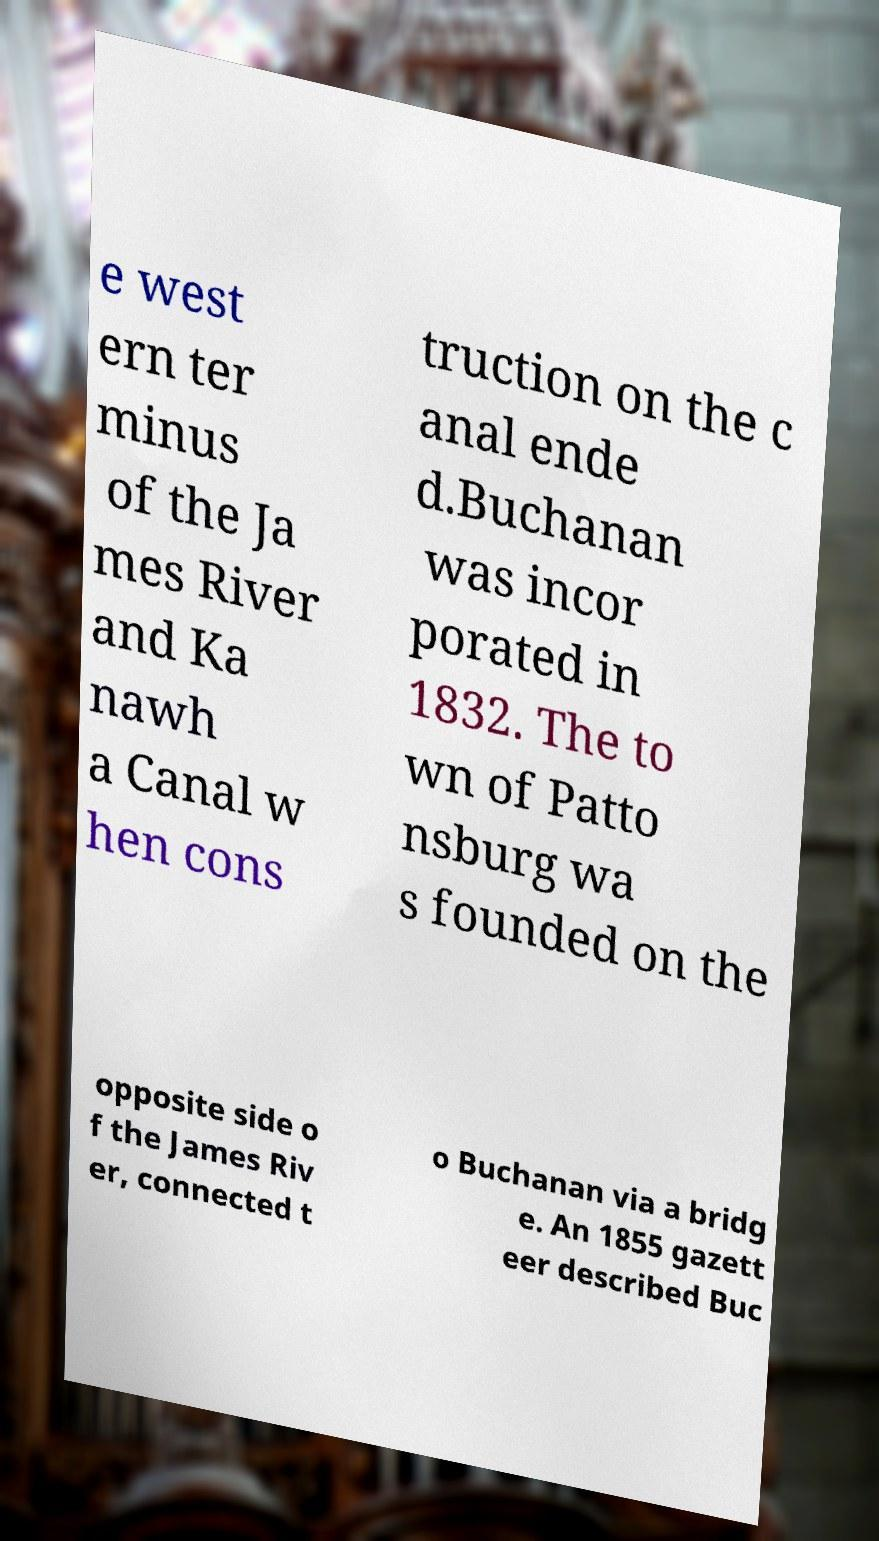What messages or text are displayed in this image? I need them in a readable, typed format. e west ern ter minus of the Ja mes River and Ka nawh a Canal w hen cons truction on the c anal ende d.Buchanan was incor porated in 1832. The to wn of Patto nsburg wa s founded on the opposite side o f the James Riv er, connected t o Buchanan via a bridg e. An 1855 gazett eer described Buc 